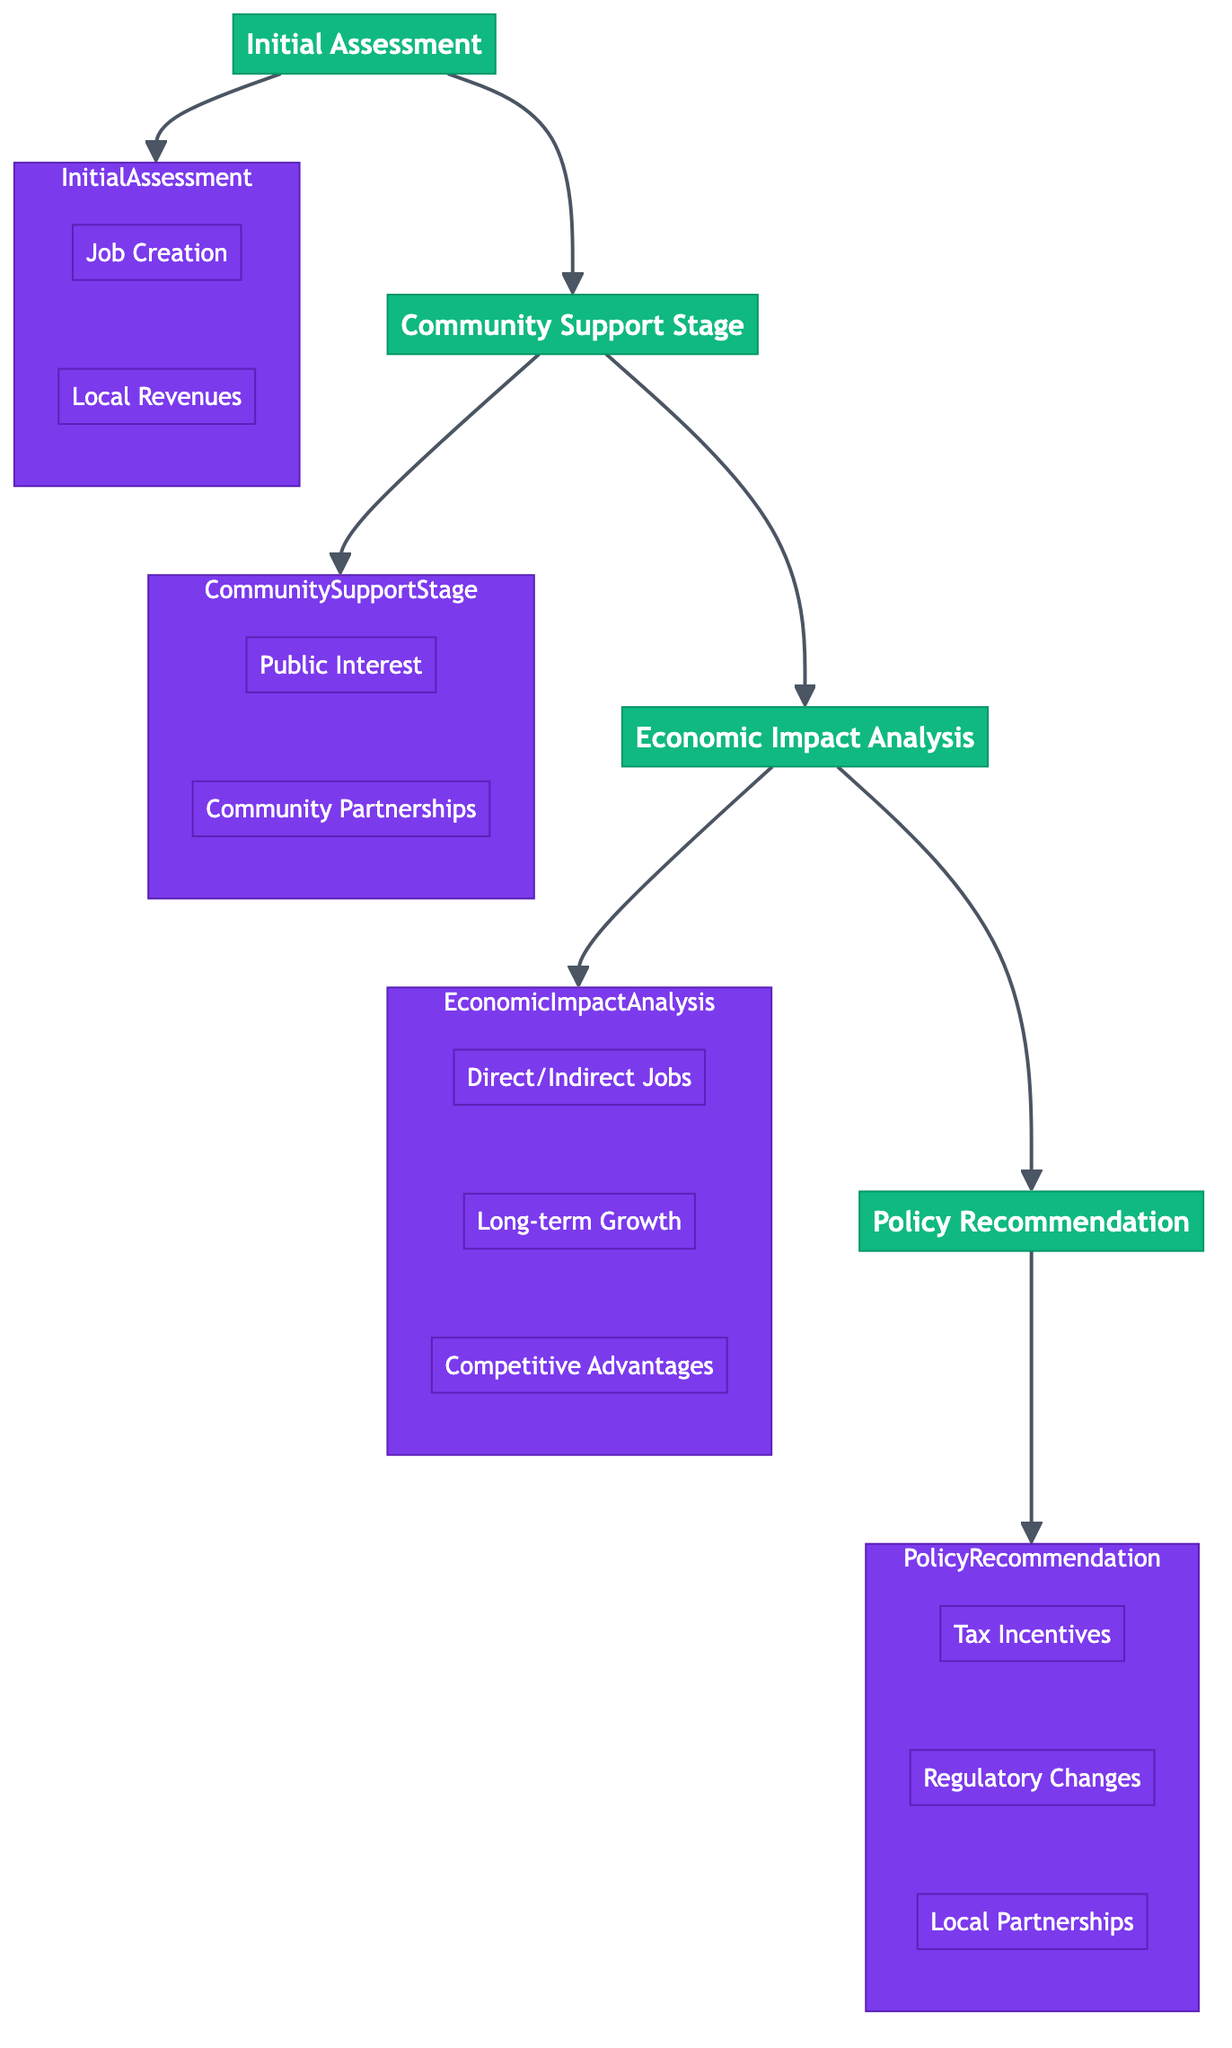What is the first stage in the pathway? The diagram shows the flow starting with "Initial Assessment" as the first stage leading to the next stages.
Answer: Initial Assessment How many stages are there in the pathway? The diagram consists of four distinct stages: Initial Assessment, Community Support Stage, Economic Impact Analysis, and Policy Recommendation.
Answer: Four What are the key considerations in the Economic Impact Analysis stage? By examining the nodes in the Economic Impact Analysis stage, we identify three key considerations: direct and indirect job creation, long-term economic growth, and competitive advantages for local businesses.
Answer: Direct/Indirect Jobs, Long-term Growth, Competitive Advantages Which stage follows the Community Support Stage? Following the Community Support Stage, the diagram outlines the Economic Impact Analysis as the next stage in the pathway.
Answer: Economic Impact Analysis What is the last stage in the pathway? The diagram indicates that the final stage in the pathway is Policy Recommendation.
Answer: Policy Recommendation What is one key consideration in the Initial Assessment stage? In the Initial Assessment stage, job creation is noted as one of the key considerations essential for evaluating economic benefits.
Answer: Job Creation How does the Community Support Stage lead to the next stage? The flow indicates that after assessing the Community Support Stage, it transitions directly to the Economic Impact Analysis, emphasizing the sequential processing of these evaluations.
Answer: Economic Impact Analysis What type of entities are involved in assessing community support? Community support is evaluated by engaging with entities such as Gallup Polls, Pew Research Center, and the Local Chamber of Commerce which contribute to understanding public opinion and community feedback.
Answer: Gallup Polls, Pew Research Center, Local Chamber of Commerce What does the Policy Recommendation suggest regarding partnerships? The recommendation stage suggests forming partnerships with local suppliers and farmers to enhance local economic development through collaboration.
Answer: Local Partnerships 